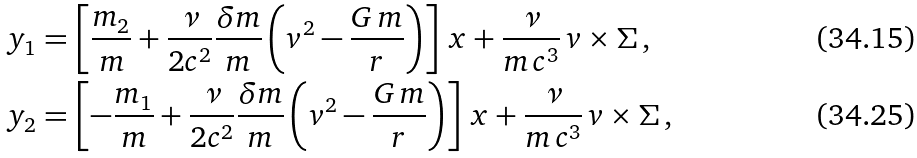Convert formula to latex. <formula><loc_0><loc_0><loc_500><loc_500>y _ { 1 } & = \left [ \frac { m _ { 2 } } { m } + \frac { \nu } { 2 c ^ { 2 } } \frac { \delta m } { m } \left ( v ^ { 2 } - \frac { G \, m } { r } \right ) \right ] \, x + \frac { \nu } { m \, c ^ { 3 } } \, v \times \Sigma \, , \\ y _ { 2 } & = \left [ - \frac { m _ { 1 } } { m } + \frac { \nu } { 2 c ^ { 2 } } \frac { \delta m } { m } \left ( v ^ { 2 } - \frac { G \, m } { r } \right ) \right ] \, x + \frac { \nu } { m \, c ^ { 3 } } \, v \times \Sigma \, ,</formula> 